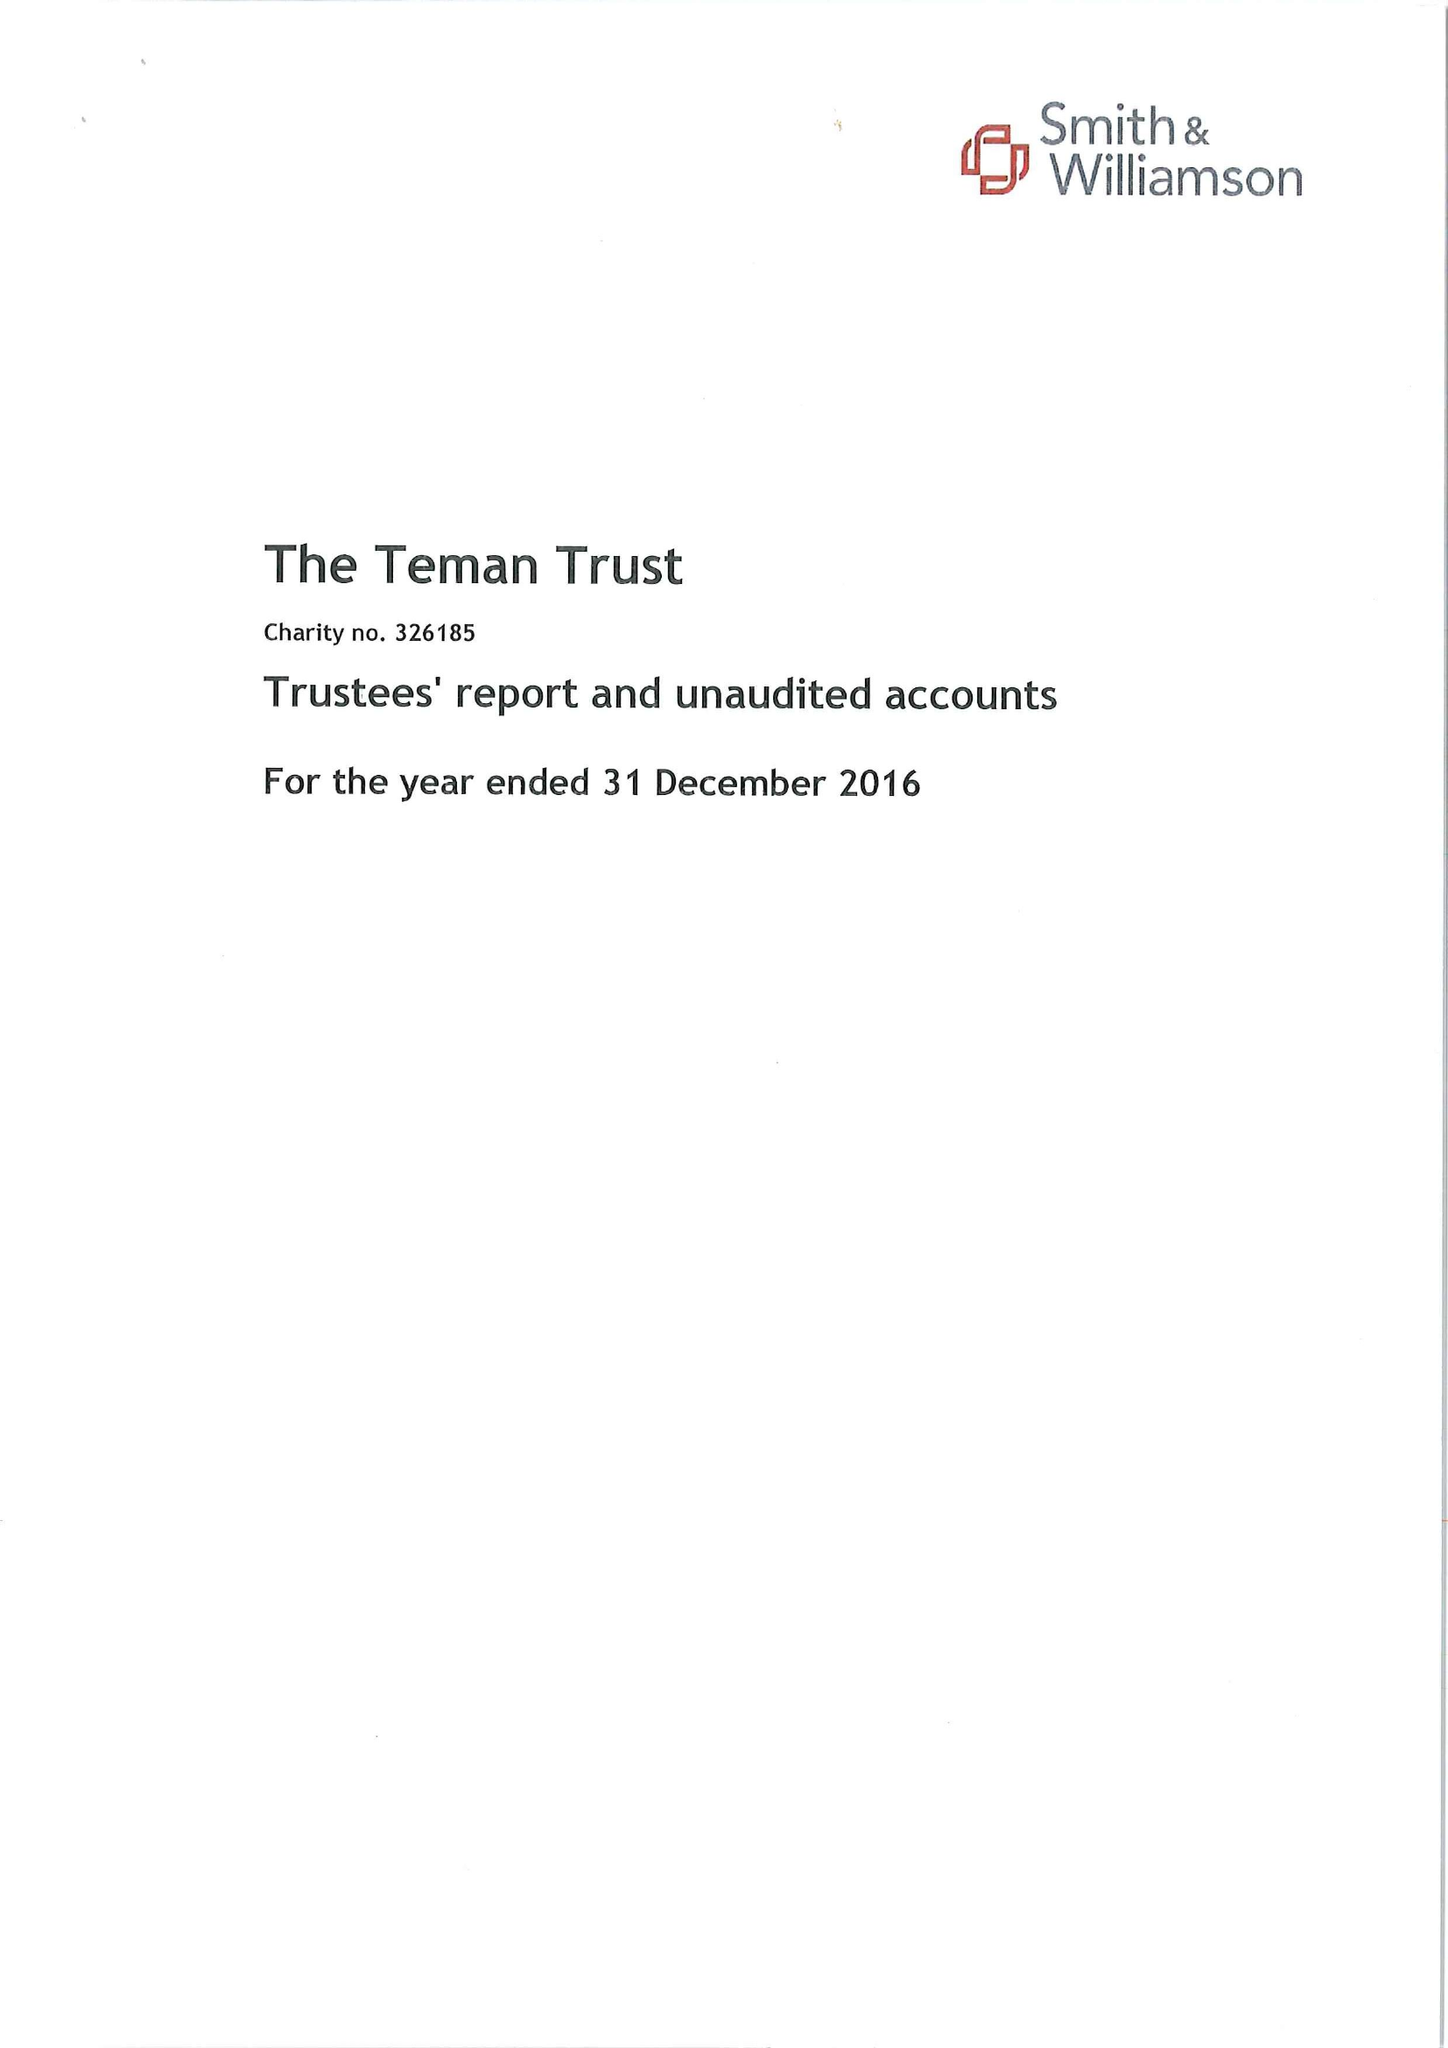What is the value for the report_date?
Answer the question using a single word or phrase. 2016-12-31 